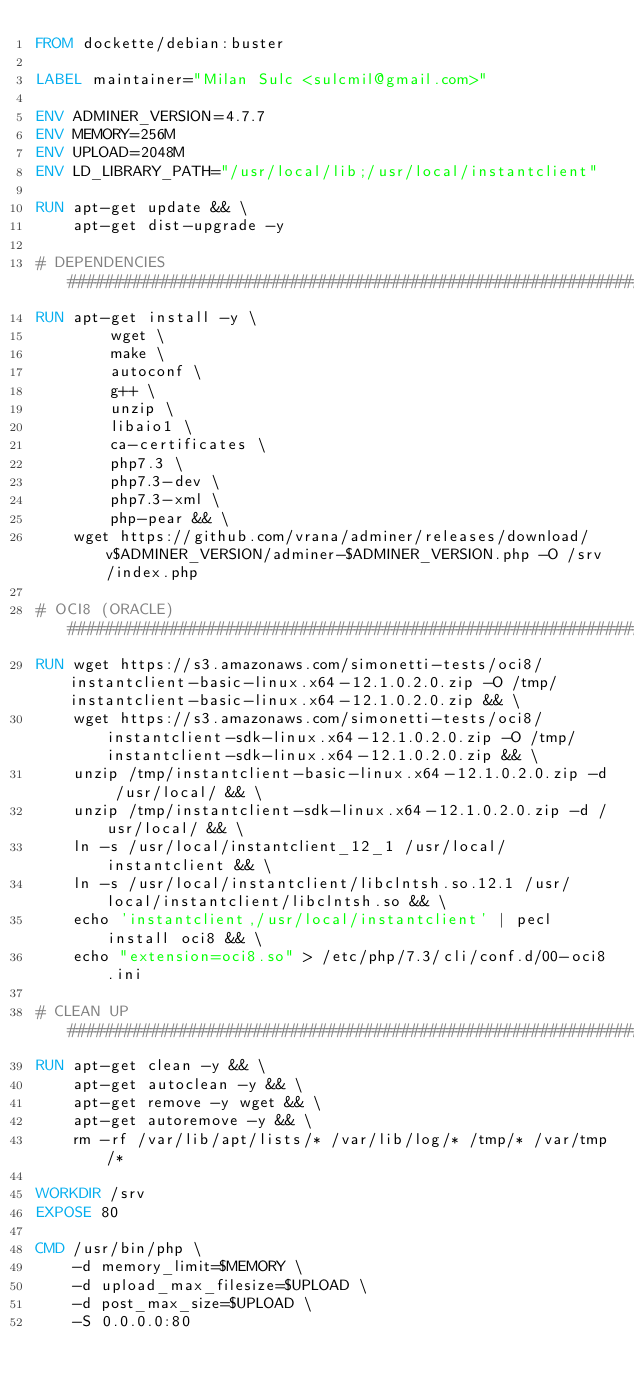<code> <loc_0><loc_0><loc_500><loc_500><_Dockerfile_>FROM dockette/debian:buster

LABEL maintainer="Milan Sulc <sulcmil@gmail.com>"

ENV ADMINER_VERSION=4.7.7
ENV MEMORY=256M
ENV UPLOAD=2048M
ENV LD_LIBRARY_PATH="/usr/local/lib;/usr/local/instantclient"

RUN apt-get update && \
    apt-get dist-upgrade -y

# DEPENDENCIES #################################################################
RUN apt-get install -y \
        wget \
        make \
        autoconf \
        g++ \
        unzip \
        libaio1 \
        ca-certificates \
        php7.3 \
        php7.3-dev \
        php7.3-xml \
        php-pear && \
    wget https://github.com/vrana/adminer/releases/download/v$ADMINER_VERSION/adminer-$ADMINER_VERSION.php -O /srv/index.php

# OCI8 (ORACLE) ################################################################
RUN wget https://s3.amazonaws.com/simonetti-tests/oci8/instantclient-basic-linux.x64-12.1.0.2.0.zip -O /tmp/instantclient-basic-linux.x64-12.1.0.2.0.zip && \
    wget https://s3.amazonaws.com/simonetti-tests/oci8/instantclient-sdk-linux.x64-12.1.0.2.0.zip -O /tmp/instantclient-sdk-linux.x64-12.1.0.2.0.zip && \
    unzip /tmp/instantclient-basic-linux.x64-12.1.0.2.0.zip -d /usr/local/ && \
    unzip /tmp/instantclient-sdk-linux.x64-12.1.0.2.0.zip -d /usr/local/ && \
    ln -s /usr/local/instantclient_12_1 /usr/local/instantclient && \
    ln -s /usr/local/instantclient/libclntsh.so.12.1 /usr/local/instantclient/libclntsh.so && \
    echo 'instantclient,/usr/local/instantclient' | pecl install oci8 && \
    echo "extension=oci8.so" > /etc/php/7.3/cli/conf.d/00-oci8.ini

# CLEAN UP #####################################################################
RUN apt-get clean -y && \
    apt-get autoclean -y && \
    apt-get remove -y wget && \
    apt-get autoremove -y && \
    rm -rf /var/lib/apt/lists/* /var/lib/log/* /tmp/* /var/tmp/*

WORKDIR /srv
EXPOSE 80

CMD /usr/bin/php \
    -d memory_limit=$MEMORY \
    -d upload_max_filesize=$UPLOAD \
    -d post_max_size=$UPLOAD \
    -S 0.0.0.0:80
</code> 